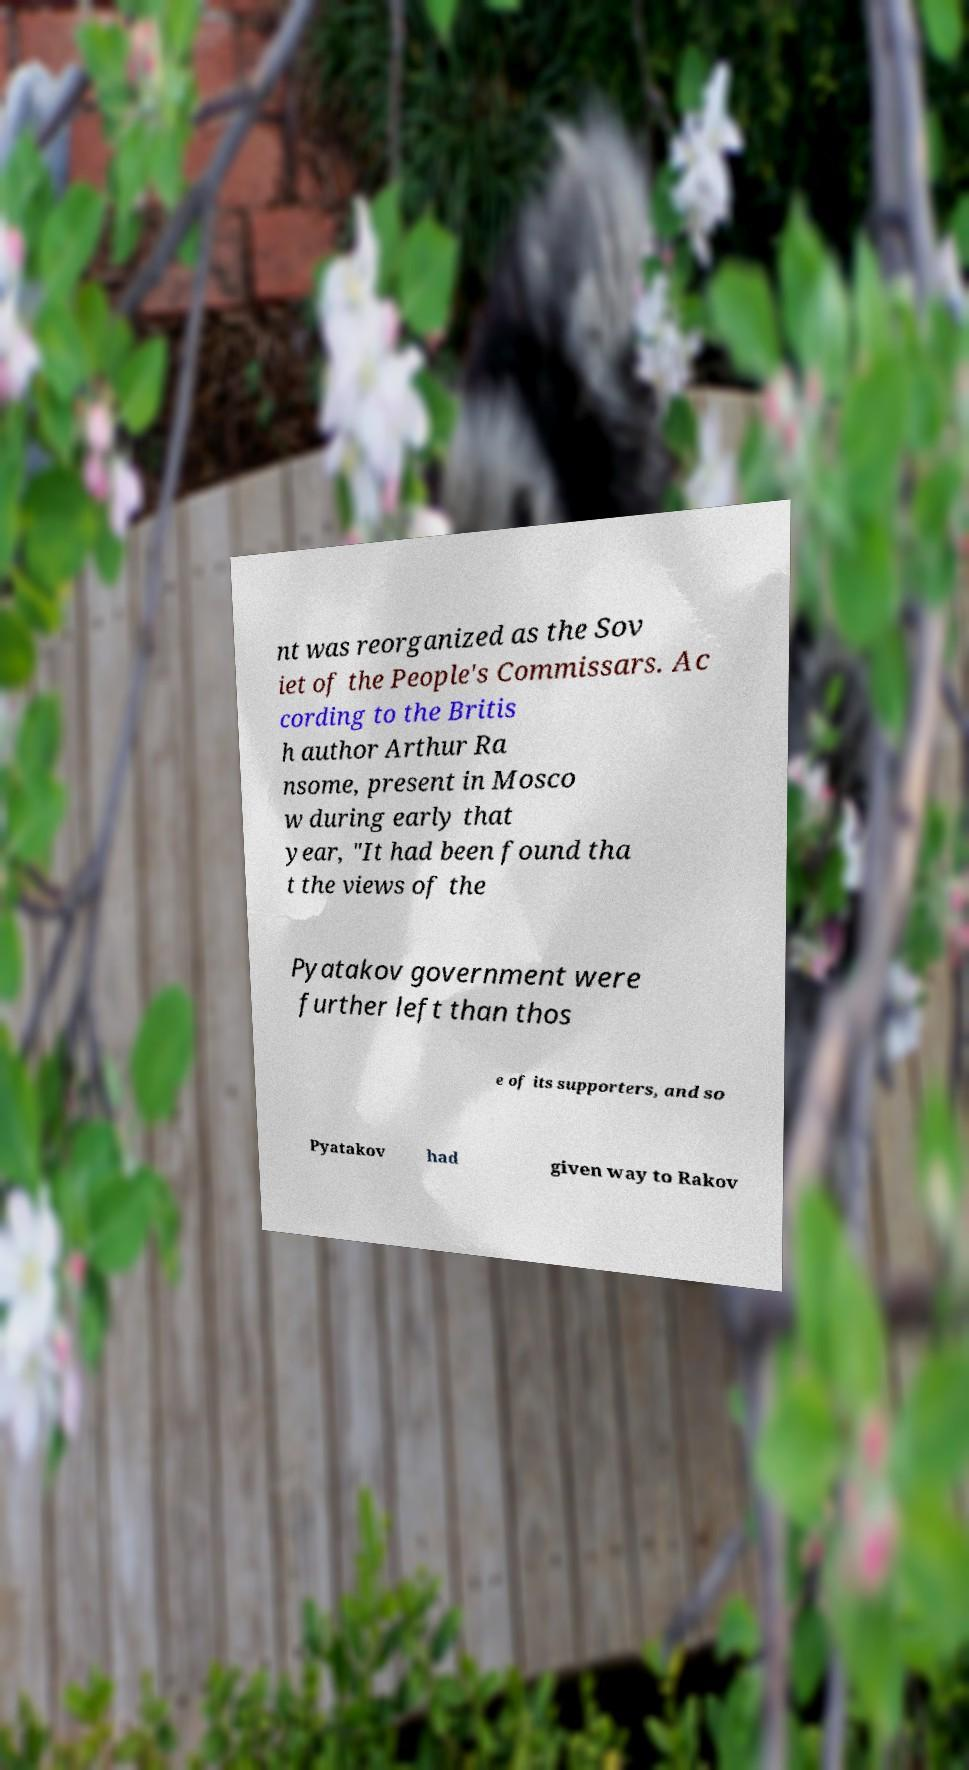There's text embedded in this image that I need extracted. Can you transcribe it verbatim? nt was reorganized as the Sov iet of the People's Commissars. Ac cording to the Britis h author Arthur Ra nsome, present in Mosco w during early that year, "It had been found tha t the views of the Pyatakov government were further left than thos e of its supporters, and so Pyatakov had given way to Rakov 